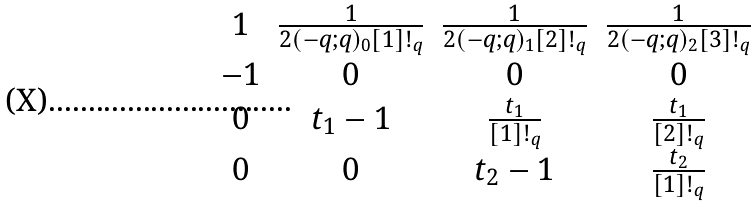<formula> <loc_0><loc_0><loc_500><loc_500>\begin{matrix} 1 & \frac { 1 } { 2 ( - q ; q ) _ { 0 } [ 1 ] ! _ { q } } & \frac { 1 } { 2 ( - q ; q ) _ { 1 } [ 2 ] ! _ { q } } & \frac { 1 } { 2 ( - q ; q ) _ { 2 } [ 3 ] ! _ { q } } \\ - 1 & 0 & 0 & 0 \\ 0 & t _ { 1 } - 1 & \frac { t _ { 1 } } { [ 1 ] ! _ { q } } & \frac { t _ { 1 } } { [ 2 ] ! _ { q } } \\ 0 & 0 & t _ { 2 } - 1 & \frac { t _ { 2 } } { [ 1 ] ! _ { q } } \end{matrix}</formula> 